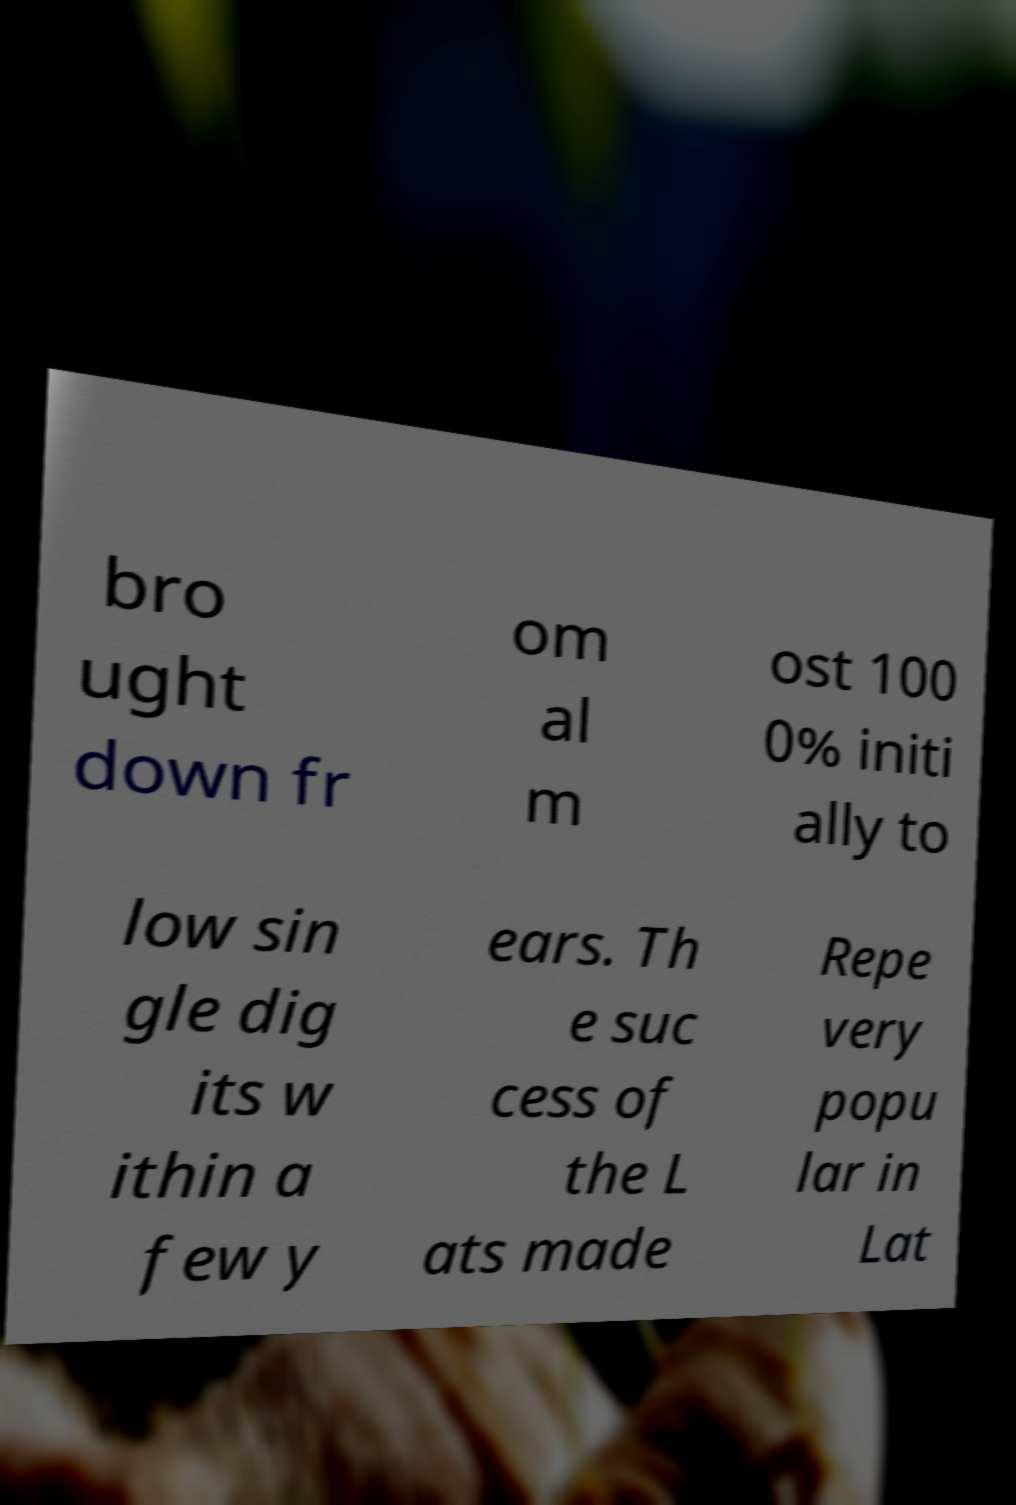I need the written content from this picture converted into text. Can you do that? bro ught down fr om al m ost 100 0% initi ally to low sin gle dig its w ithin a few y ears. Th e suc cess of the L ats made Repe very popu lar in Lat 